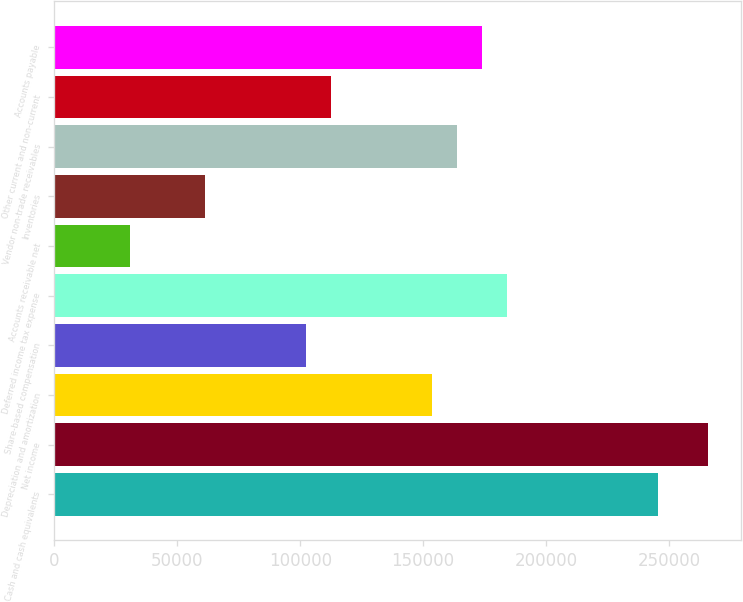Convert chart to OTSL. <chart><loc_0><loc_0><loc_500><loc_500><bar_chart><fcel>Cash and cash equivalents<fcel>Net income<fcel>Depreciation and amortization<fcel>Share-based compensation<fcel>Deferred income tax expense<fcel>Accounts receivable net<fcel>Inventories<fcel>Vendor non-trade receivables<fcel>Other current and non-current<fcel>Accounts payable<nl><fcel>245559<fcel>266022<fcel>153475<fcel>102317<fcel>184170<fcel>30695.9<fcel>61390.7<fcel>163706<fcel>112549<fcel>173938<nl></chart> 